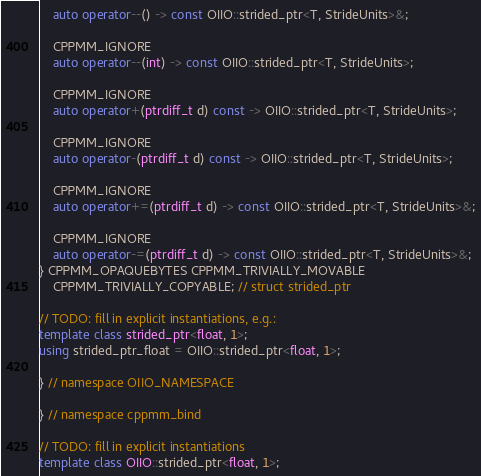<code> <loc_0><loc_0><loc_500><loc_500><_C++_>    auto operator--() -> const OIIO::strided_ptr<T, StrideUnits>&;

    CPPMM_IGNORE
    auto operator--(int) -> const OIIO::strided_ptr<T, StrideUnits>;

    CPPMM_IGNORE
    auto operator+(ptrdiff_t d) const -> OIIO::strided_ptr<T, StrideUnits>;

    CPPMM_IGNORE
    auto operator-(ptrdiff_t d) const -> OIIO::strided_ptr<T, StrideUnits>;

    CPPMM_IGNORE
    auto operator+=(ptrdiff_t d) -> const OIIO::strided_ptr<T, StrideUnits>&;

    CPPMM_IGNORE
    auto operator-=(ptrdiff_t d) -> const OIIO::strided_ptr<T, StrideUnits>&;
} CPPMM_OPAQUEBYTES CPPMM_TRIVIALLY_MOVABLE
    CPPMM_TRIVIALLY_COPYABLE; // struct strided_ptr

// TODO: fill in explicit instantiations, e.g.:
template class strided_ptr<float, 1>;
using strided_ptr_float = OIIO::strided_ptr<float, 1>;

} // namespace OIIO_NAMESPACE

} // namespace cppmm_bind

// TODO: fill in explicit instantiations
template class OIIO::strided_ptr<float, 1>;
</code> 